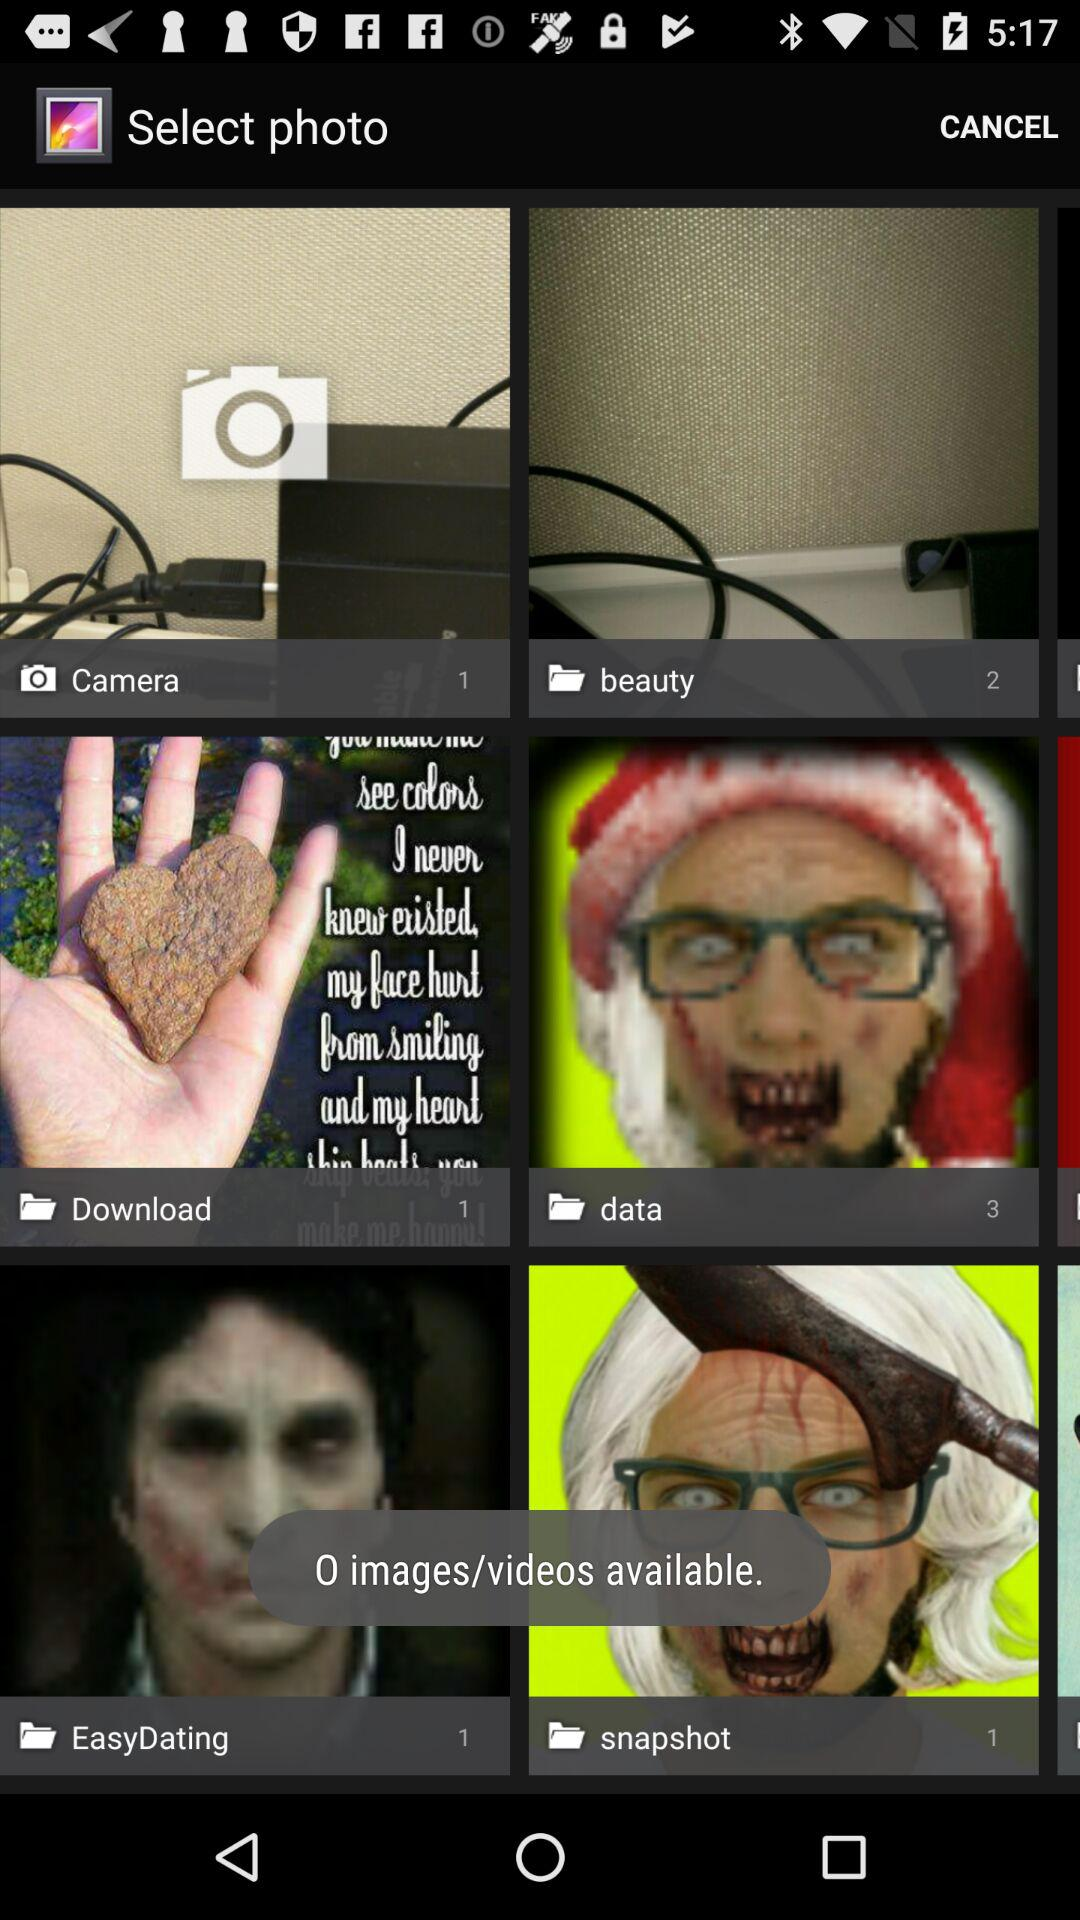How many images are there in the "beauty" folder? There are 2 images in the "beauty" folder. 